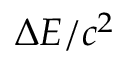Convert formula to latex. <formula><loc_0><loc_0><loc_500><loc_500>\Delta E / c ^ { 2 }</formula> 